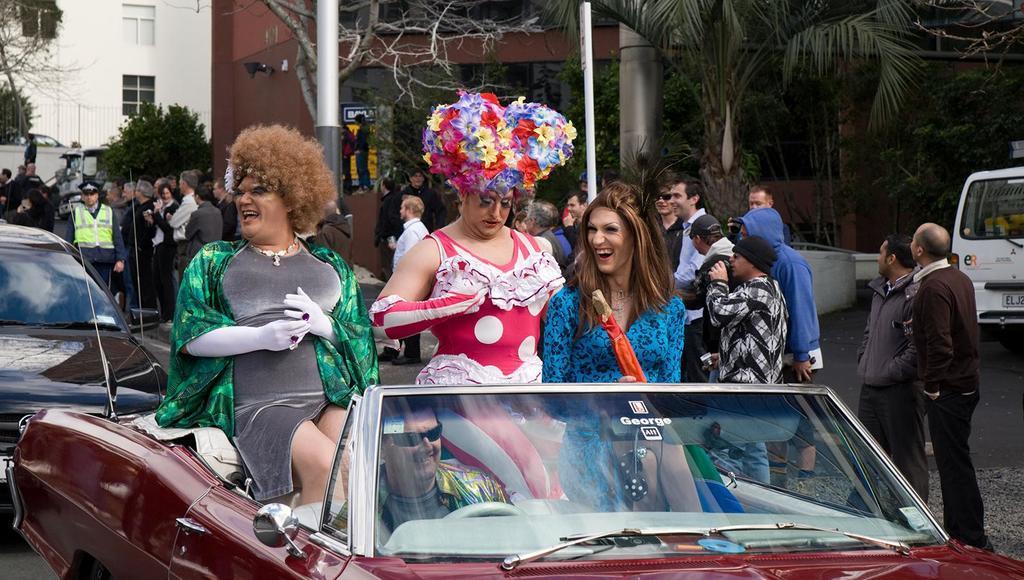In one or two sentences, can you explain what this image depicts? There are three person sitting on car and a man wearing a specs is on the driving seat. And the persons are wearing something on their head. In the back there is another car. In the background there are many people standing, building, trees, pillars, vehicles, windows. And a person wearing a jacket and cap is standing in the background. 